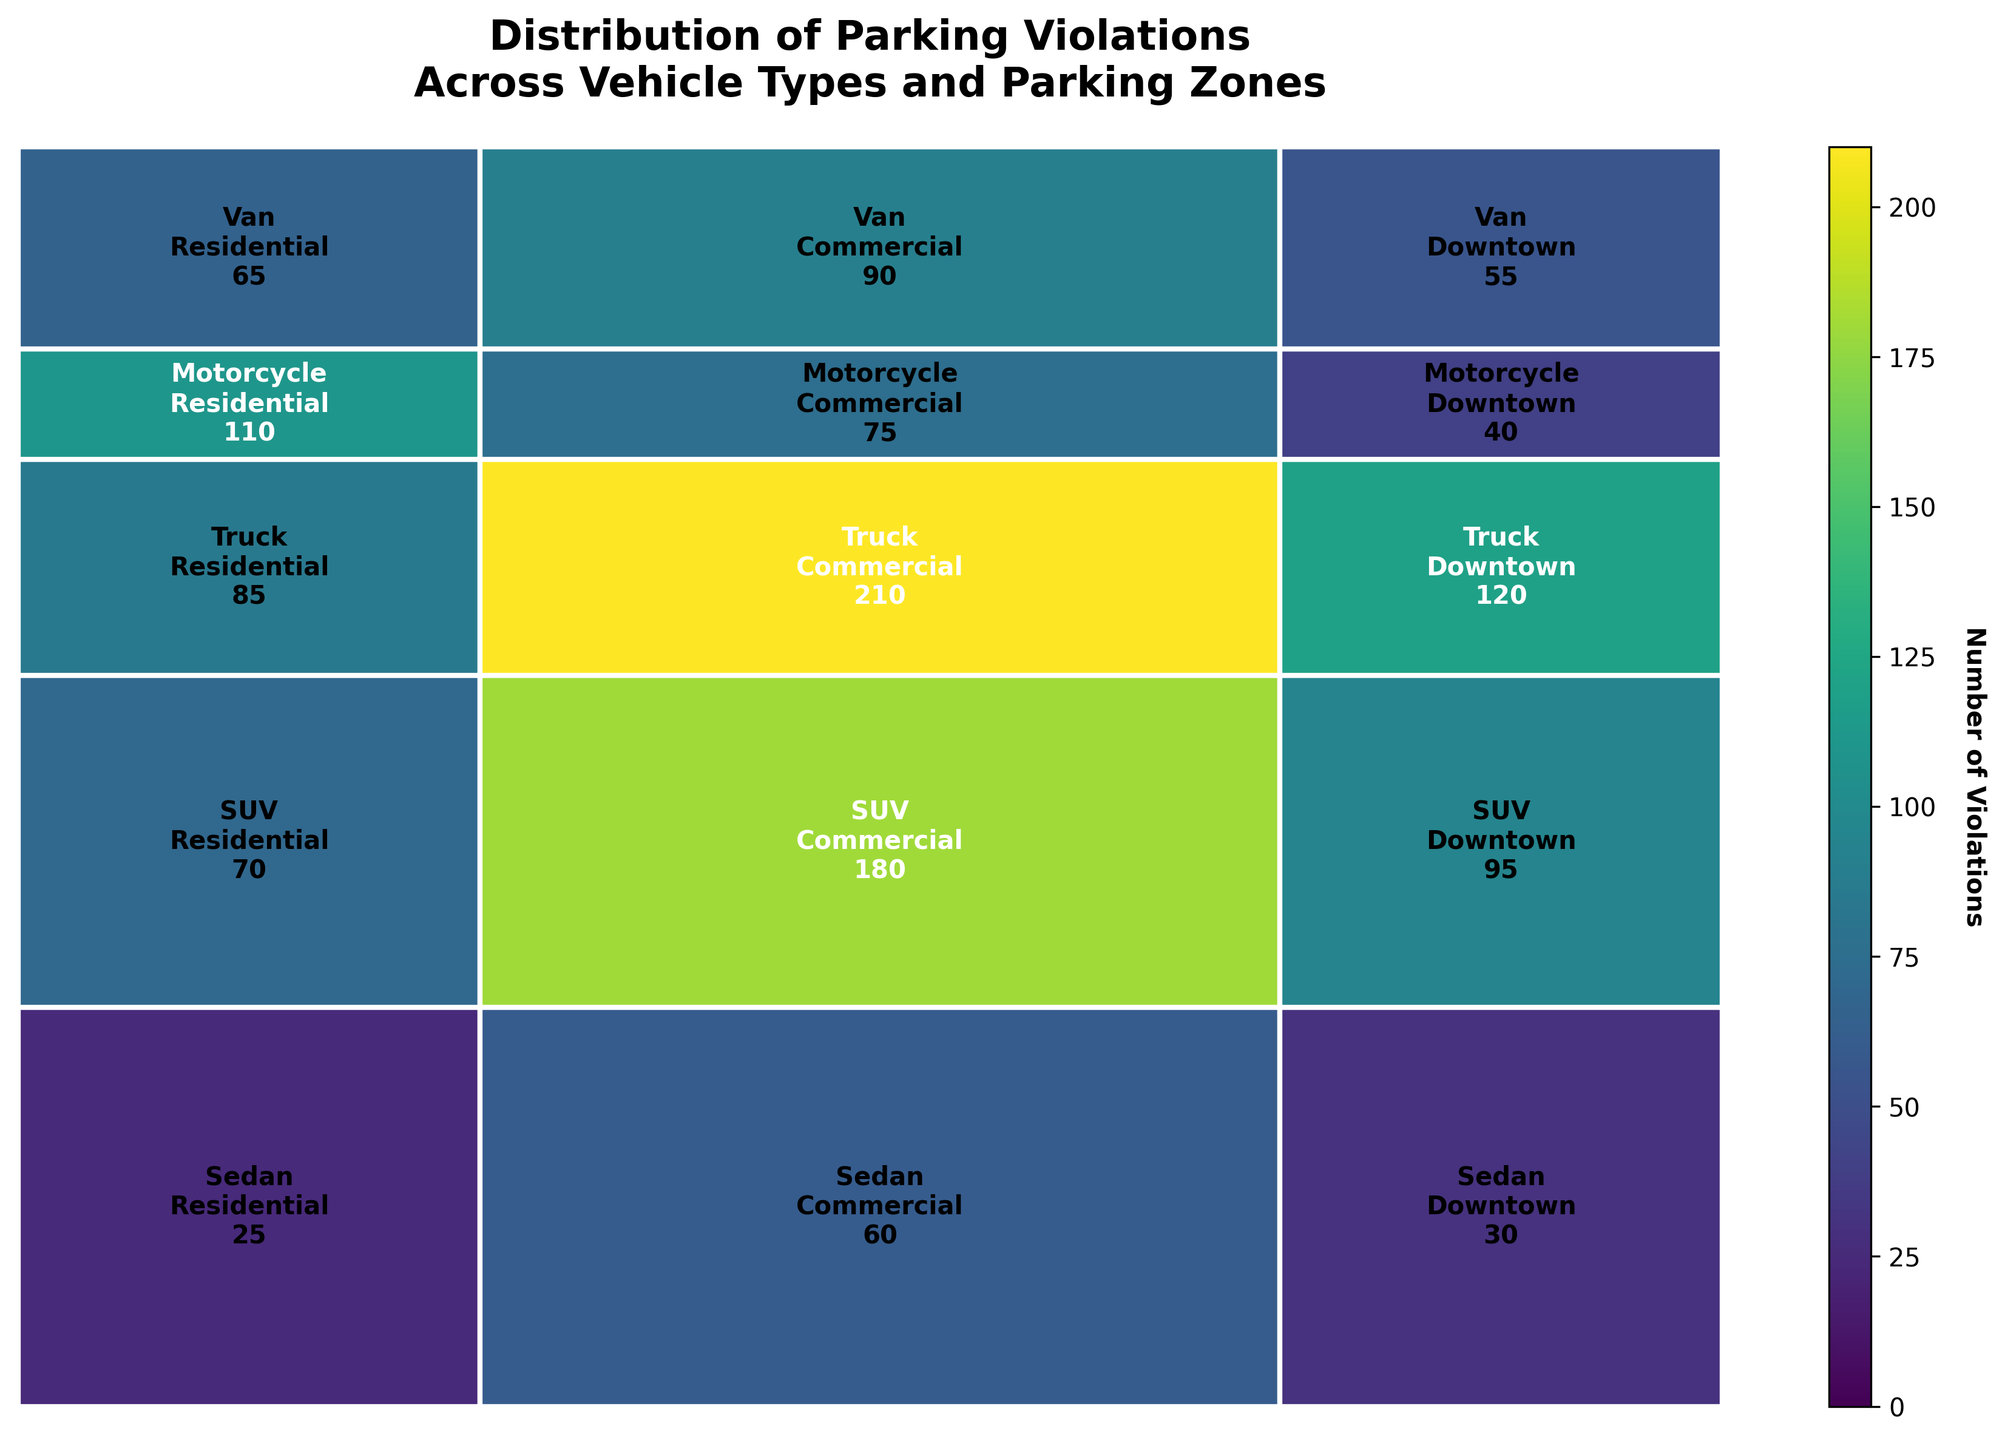What is the title of the plot? The title is prominently displayed at the top of the plot in bold text. It reads: "Distribution of Parking Violations Across Vehicle Types and Parking Zones".
Answer: Distribution of Parking Violations Across Vehicle Types and Parking Zones Which vehicle type has the most violations overall? To find the vehicle type with the most violations, observe which horizontal section spans the largest total width. The 'Sedan' section extends the most, indicating the highest number of violations.
Answer: Sedan Which parking zone has the highest number of violations? To identify the parking zone with the most violations, look at which vertical section spans the largest total height. The 'Downtown' section extends the most, indicating it has the highest number of violations.
Answer: Downtown How do the violations for SUVs in the Commercial zone compare to those for Trucks in the same zone? Compare the sizes of the two rectangles for SUVs and Trucks in the Commercial zone. The rectangle for SUVs appears smaller than the rectangle for Trucks in the Commercial zone, indicating fewer violations for SUVs.
Answer: Trucks have more violations Which combination of vehicle type and parking zone has the least number of violations? Search for the smallest rectangle in the mosaic plot. The smallest rectangle corresponds to 'Motorcycle' in the 'Commercial' zone, indicating it has the least number of violations.
Answer: Motorcycle in Commercial How do the violations for Vans in the Residential zone compare to those for SUVs in the same zone? Compare the sizes of the rectangles for Vans and SUVs in the Residential zone. The rectangle for Vans appears smaller than that for SUVs, indicating fewer violations for Vans.
Answer: SUVs have more violations What is the count of truck violations in the Residential zone? The count is represented by the number within the rectangle for Trucks in the Residential zone. This rectangle shows the number '40'.
Answer: 40 How much more is the number of sedan violations in Downtown compared to the Commercial zone? Identify the numbers in the rectangles for Sedans in both Downtown and Commercial zones: 210 and 85 respectively. Subtracting 85 from 210 gives the difference. 210 - 85 = 125.
Answer: 125 What proportion of total violations is represented by SUVs in the Downtown zone? To calculate the proportion, identify the number of SUV violations in Downtown (180) and divide by the total number of violations (1205). The result is approximately 0.1494.
Answer: 0.1494 Do motorcycles have more violations in Residential zones or Commercial zones? Compare the sizes of the rectangles and the numbers in them for motorcycles in Residential (30) and Commercial (25) zones. Motorcycles have more violations in Residential zones.
Answer: Residential zones 